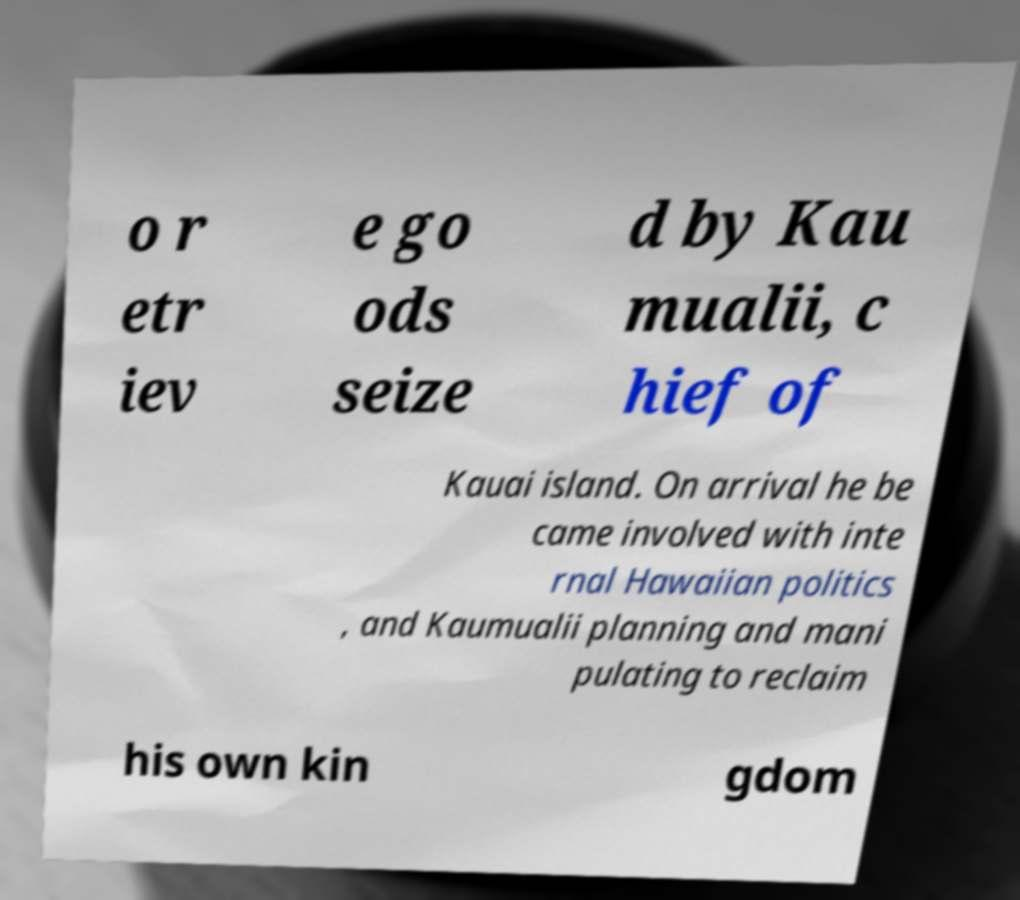For documentation purposes, I need the text within this image transcribed. Could you provide that? o r etr iev e go ods seize d by Kau mualii, c hief of Kauai island. On arrival he be came involved with inte rnal Hawaiian politics , and Kaumualii planning and mani pulating to reclaim his own kin gdom 